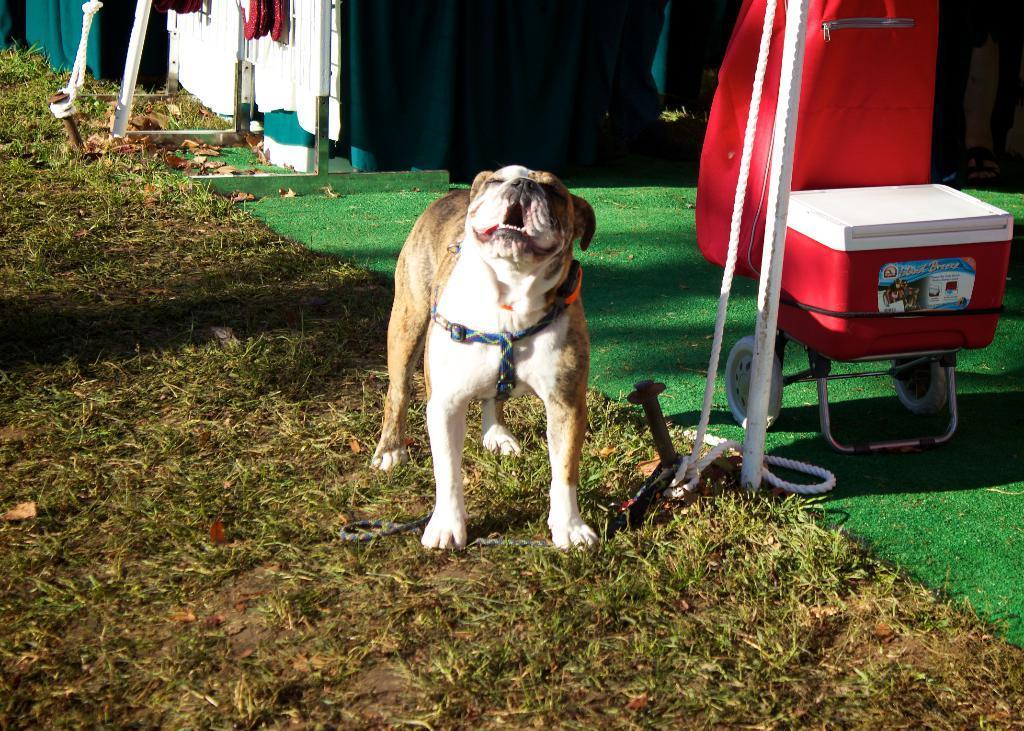Can you describe this image briefly? In the center of the image there is a dog. At the bottom of the image there is grass. In the background of the image there are tents. To the right side bottom of the image there is a green color carpet. 